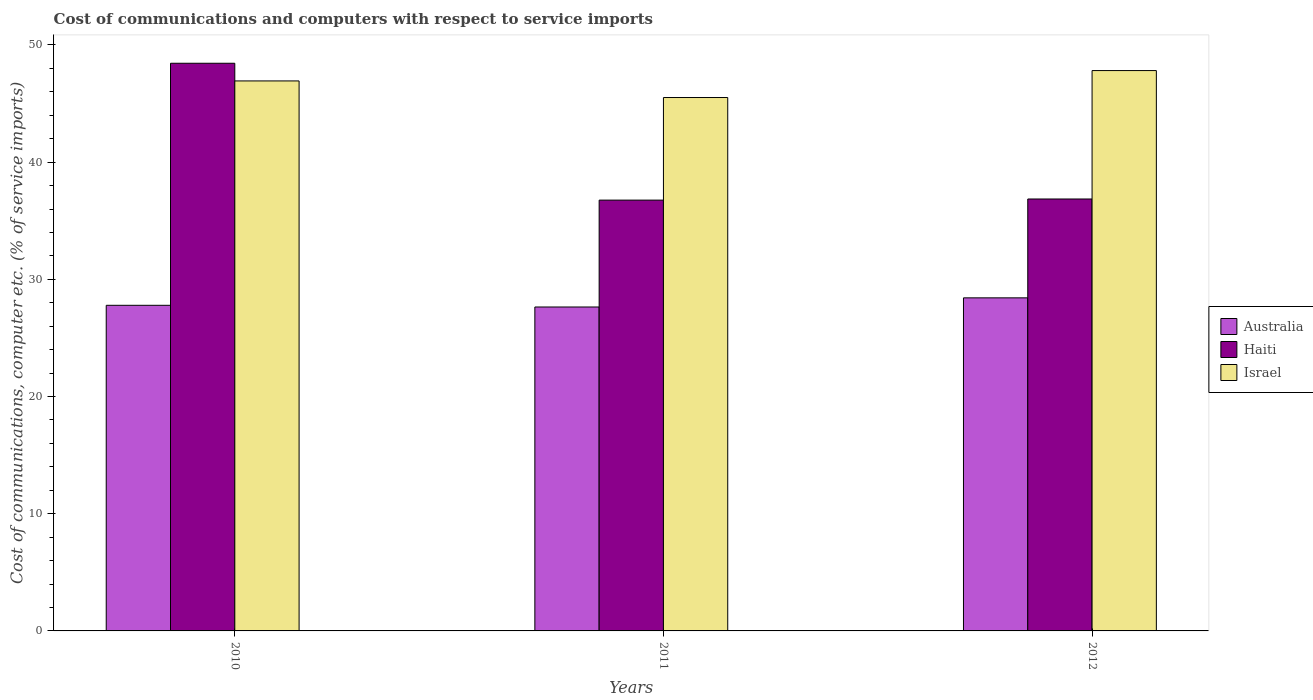How many groups of bars are there?
Keep it short and to the point. 3. How many bars are there on the 3rd tick from the left?
Make the answer very short. 3. How many bars are there on the 2nd tick from the right?
Offer a very short reply. 3. What is the cost of communications and computers in Haiti in 2010?
Offer a terse response. 48.44. Across all years, what is the maximum cost of communications and computers in Australia?
Ensure brevity in your answer.  28.42. Across all years, what is the minimum cost of communications and computers in Israel?
Keep it short and to the point. 45.52. In which year was the cost of communications and computers in Haiti maximum?
Provide a short and direct response. 2010. What is the total cost of communications and computers in Australia in the graph?
Your response must be concise. 83.85. What is the difference between the cost of communications and computers in Israel in 2010 and that in 2012?
Provide a short and direct response. -0.88. What is the difference between the cost of communications and computers in Israel in 2010 and the cost of communications and computers in Australia in 2012?
Give a very brief answer. 18.51. What is the average cost of communications and computers in Haiti per year?
Your response must be concise. 40.69. In the year 2011, what is the difference between the cost of communications and computers in Israel and cost of communications and computers in Haiti?
Keep it short and to the point. 8.75. What is the ratio of the cost of communications and computers in Israel in 2010 to that in 2012?
Provide a succinct answer. 0.98. Is the difference between the cost of communications and computers in Israel in 2010 and 2012 greater than the difference between the cost of communications and computers in Haiti in 2010 and 2012?
Make the answer very short. No. What is the difference between the highest and the second highest cost of communications and computers in Israel?
Provide a short and direct response. 0.88. What is the difference between the highest and the lowest cost of communications and computers in Israel?
Provide a short and direct response. 2.3. Is the sum of the cost of communications and computers in Haiti in 2011 and 2012 greater than the maximum cost of communications and computers in Israel across all years?
Offer a very short reply. Yes. What does the 1st bar from the left in 2010 represents?
Give a very brief answer. Australia. Is it the case that in every year, the sum of the cost of communications and computers in Australia and cost of communications and computers in Haiti is greater than the cost of communications and computers in Israel?
Give a very brief answer. Yes. How many bars are there?
Your answer should be compact. 9. How many years are there in the graph?
Provide a short and direct response. 3. Are the values on the major ticks of Y-axis written in scientific E-notation?
Provide a short and direct response. No. Does the graph contain any zero values?
Offer a very short reply. No. What is the title of the graph?
Your answer should be very brief. Cost of communications and computers with respect to service imports. What is the label or title of the Y-axis?
Provide a short and direct response. Cost of communications, computer etc. (% of service imports). What is the Cost of communications, computer etc. (% of service imports) in Australia in 2010?
Ensure brevity in your answer.  27.79. What is the Cost of communications, computer etc. (% of service imports) in Haiti in 2010?
Ensure brevity in your answer.  48.44. What is the Cost of communications, computer etc. (% of service imports) in Israel in 2010?
Ensure brevity in your answer.  46.93. What is the Cost of communications, computer etc. (% of service imports) of Australia in 2011?
Your response must be concise. 27.64. What is the Cost of communications, computer etc. (% of service imports) of Haiti in 2011?
Provide a succinct answer. 36.76. What is the Cost of communications, computer etc. (% of service imports) in Israel in 2011?
Ensure brevity in your answer.  45.52. What is the Cost of communications, computer etc. (% of service imports) in Australia in 2012?
Offer a very short reply. 28.42. What is the Cost of communications, computer etc. (% of service imports) of Haiti in 2012?
Your answer should be very brief. 36.86. What is the Cost of communications, computer etc. (% of service imports) of Israel in 2012?
Offer a terse response. 47.82. Across all years, what is the maximum Cost of communications, computer etc. (% of service imports) in Australia?
Provide a short and direct response. 28.42. Across all years, what is the maximum Cost of communications, computer etc. (% of service imports) in Haiti?
Offer a terse response. 48.44. Across all years, what is the maximum Cost of communications, computer etc. (% of service imports) in Israel?
Give a very brief answer. 47.82. Across all years, what is the minimum Cost of communications, computer etc. (% of service imports) in Australia?
Make the answer very short. 27.64. Across all years, what is the minimum Cost of communications, computer etc. (% of service imports) of Haiti?
Provide a short and direct response. 36.76. Across all years, what is the minimum Cost of communications, computer etc. (% of service imports) in Israel?
Make the answer very short. 45.52. What is the total Cost of communications, computer etc. (% of service imports) of Australia in the graph?
Provide a succinct answer. 83.85. What is the total Cost of communications, computer etc. (% of service imports) in Haiti in the graph?
Provide a short and direct response. 122.06. What is the total Cost of communications, computer etc. (% of service imports) in Israel in the graph?
Make the answer very short. 140.26. What is the difference between the Cost of communications, computer etc. (% of service imports) of Australia in 2010 and that in 2011?
Provide a succinct answer. 0.14. What is the difference between the Cost of communications, computer etc. (% of service imports) in Haiti in 2010 and that in 2011?
Offer a terse response. 11.68. What is the difference between the Cost of communications, computer etc. (% of service imports) of Israel in 2010 and that in 2011?
Give a very brief answer. 1.42. What is the difference between the Cost of communications, computer etc. (% of service imports) of Australia in 2010 and that in 2012?
Make the answer very short. -0.64. What is the difference between the Cost of communications, computer etc. (% of service imports) in Haiti in 2010 and that in 2012?
Your answer should be compact. 11.58. What is the difference between the Cost of communications, computer etc. (% of service imports) in Israel in 2010 and that in 2012?
Your response must be concise. -0.88. What is the difference between the Cost of communications, computer etc. (% of service imports) of Australia in 2011 and that in 2012?
Offer a very short reply. -0.78. What is the difference between the Cost of communications, computer etc. (% of service imports) in Haiti in 2011 and that in 2012?
Offer a terse response. -0.1. What is the difference between the Cost of communications, computer etc. (% of service imports) of Israel in 2011 and that in 2012?
Your response must be concise. -2.3. What is the difference between the Cost of communications, computer etc. (% of service imports) in Australia in 2010 and the Cost of communications, computer etc. (% of service imports) in Haiti in 2011?
Offer a terse response. -8.98. What is the difference between the Cost of communications, computer etc. (% of service imports) in Australia in 2010 and the Cost of communications, computer etc. (% of service imports) in Israel in 2011?
Give a very brief answer. -17.73. What is the difference between the Cost of communications, computer etc. (% of service imports) of Haiti in 2010 and the Cost of communications, computer etc. (% of service imports) of Israel in 2011?
Ensure brevity in your answer.  2.92. What is the difference between the Cost of communications, computer etc. (% of service imports) in Australia in 2010 and the Cost of communications, computer etc. (% of service imports) in Haiti in 2012?
Offer a very short reply. -9.07. What is the difference between the Cost of communications, computer etc. (% of service imports) in Australia in 2010 and the Cost of communications, computer etc. (% of service imports) in Israel in 2012?
Give a very brief answer. -20.03. What is the difference between the Cost of communications, computer etc. (% of service imports) in Haiti in 2010 and the Cost of communications, computer etc. (% of service imports) in Israel in 2012?
Provide a succinct answer. 0.62. What is the difference between the Cost of communications, computer etc. (% of service imports) of Australia in 2011 and the Cost of communications, computer etc. (% of service imports) of Haiti in 2012?
Provide a succinct answer. -9.22. What is the difference between the Cost of communications, computer etc. (% of service imports) in Australia in 2011 and the Cost of communications, computer etc. (% of service imports) in Israel in 2012?
Offer a terse response. -20.17. What is the difference between the Cost of communications, computer etc. (% of service imports) in Haiti in 2011 and the Cost of communications, computer etc. (% of service imports) in Israel in 2012?
Keep it short and to the point. -11.05. What is the average Cost of communications, computer etc. (% of service imports) of Australia per year?
Ensure brevity in your answer.  27.95. What is the average Cost of communications, computer etc. (% of service imports) of Haiti per year?
Your response must be concise. 40.69. What is the average Cost of communications, computer etc. (% of service imports) in Israel per year?
Provide a short and direct response. 46.75. In the year 2010, what is the difference between the Cost of communications, computer etc. (% of service imports) of Australia and Cost of communications, computer etc. (% of service imports) of Haiti?
Ensure brevity in your answer.  -20.65. In the year 2010, what is the difference between the Cost of communications, computer etc. (% of service imports) in Australia and Cost of communications, computer etc. (% of service imports) in Israel?
Provide a short and direct response. -19.15. In the year 2010, what is the difference between the Cost of communications, computer etc. (% of service imports) in Haiti and Cost of communications, computer etc. (% of service imports) in Israel?
Provide a succinct answer. 1.51. In the year 2011, what is the difference between the Cost of communications, computer etc. (% of service imports) in Australia and Cost of communications, computer etc. (% of service imports) in Haiti?
Your response must be concise. -9.12. In the year 2011, what is the difference between the Cost of communications, computer etc. (% of service imports) of Australia and Cost of communications, computer etc. (% of service imports) of Israel?
Make the answer very short. -17.87. In the year 2011, what is the difference between the Cost of communications, computer etc. (% of service imports) of Haiti and Cost of communications, computer etc. (% of service imports) of Israel?
Your response must be concise. -8.75. In the year 2012, what is the difference between the Cost of communications, computer etc. (% of service imports) in Australia and Cost of communications, computer etc. (% of service imports) in Haiti?
Your answer should be very brief. -8.44. In the year 2012, what is the difference between the Cost of communications, computer etc. (% of service imports) of Australia and Cost of communications, computer etc. (% of service imports) of Israel?
Your response must be concise. -19.39. In the year 2012, what is the difference between the Cost of communications, computer etc. (% of service imports) in Haiti and Cost of communications, computer etc. (% of service imports) in Israel?
Your response must be concise. -10.96. What is the ratio of the Cost of communications, computer etc. (% of service imports) in Haiti in 2010 to that in 2011?
Offer a terse response. 1.32. What is the ratio of the Cost of communications, computer etc. (% of service imports) of Israel in 2010 to that in 2011?
Ensure brevity in your answer.  1.03. What is the ratio of the Cost of communications, computer etc. (% of service imports) of Australia in 2010 to that in 2012?
Your response must be concise. 0.98. What is the ratio of the Cost of communications, computer etc. (% of service imports) of Haiti in 2010 to that in 2012?
Offer a terse response. 1.31. What is the ratio of the Cost of communications, computer etc. (% of service imports) of Israel in 2010 to that in 2012?
Offer a very short reply. 0.98. What is the ratio of the Cost of communications, computer etc. (% of service imports) in Australia in 2011 to that in 2012?
Offer a terse response. 0.97. What is the ratio of the Cost of communications, computer etc. (% of service imports) of Haiti in 2011 to that in 2012?
Keep it short and to the point. 1. What is the ratio of the Cost of communications, computer etc. (% of service imports) of Israel in 2011 to that in 2012?
Your answer should be very brief. 0.95. What is the difference between the highest and the second highest Cost of communications, computer etc. (% of service imports) in Australia?
Ensure brevity in your answer.  0.64. What is the difference between the highest and the second highest Cost of communications, computer etc. (% of service imports) of Haiti?
Offer a very short reply. 11.58. What is the difference between the highest and the second highest Cost of communications, computer etc. (% of service imports) in Israel?
Your answer should be very brief. 0.88. What is the difference between the highest and the lowest Cost of communications, computer etc. (% of service imports) of Australia?
Make the answer very short. 0.78. What is the difference between the highest and the lowest Cost of communications, computer etc. (% of service imports) of Haiti?
Your answer should be compact. 11.68. What is the difference between the highest and the lowest Cost of communications, computer etc. (% of service imports) of Israel?
Your answer should be very brief. 2.3. 